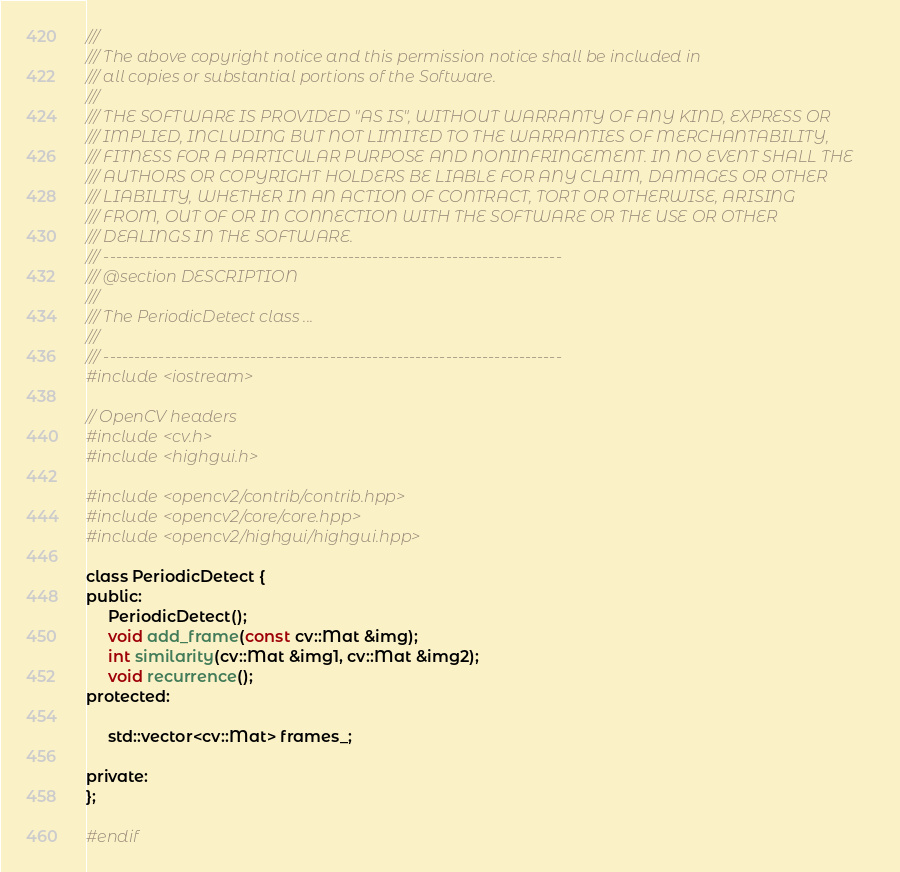<code> <loc_0><loc_0><loc_500><loc_500><_C_>/// 
/// The above copyright notice and this permission notice shall be included in 
/// all copies or substantial portions of the Software.
/// 
/// THE SOFTWARE IS PROVIDED "AS IS", WITHOUT WARRANTY OF ANY KIND, EXPRESS OR 
/// IMPLIED, INCLUDING BUT NOT LIMITED TO THE WARRANTIES OF MERCHANTABILITY, 
/// FITNESS FOR A PARTICULAR PURPOSE AND NONINFRINGEMENT. IN NO EVENT SHALL THE
/// AUTHORS OR COPYRIGHT HOLDERS BE LIABLE FOR ANY CLAIM, DAMAGES OR OTHER 
/// LIABILITY, WHETHER IN AN ACTION OF CONTRACT, TORT OR OTHERWISE, ARISING 
/// FROM, OUT OF OR IN CONNECTION WITH THE SOFTWARE OR THE USE OR OTHER 
/// DEALINGS IN THE SOFTWARE.
/// ---------------------------------------------------------------------------
/// @section DESCRIPTION
/// 
/// The PeriodicDetect class ...
/// 
/// ---------------------------------------------------------------------------
#include <iostream>

// OpenCV headers
#include <cv.h>
#include <highgui.h>

#include <opencv2/contrib/contrib.hpp>
#include <opencv2/core/core.hpp>
#include <opencv2/highgui/highgui.hpp>

class PeriodicDetect {
public:
     PeriodicDetect();
     void add_frame(const cv::Mat &img);
     int similarity(cv::Mat &img1, cv::Mat &img2);
     void recurrence();
protected:

     std::vector<cv::Mat> frames_;

private:
};

#endif
</code> 